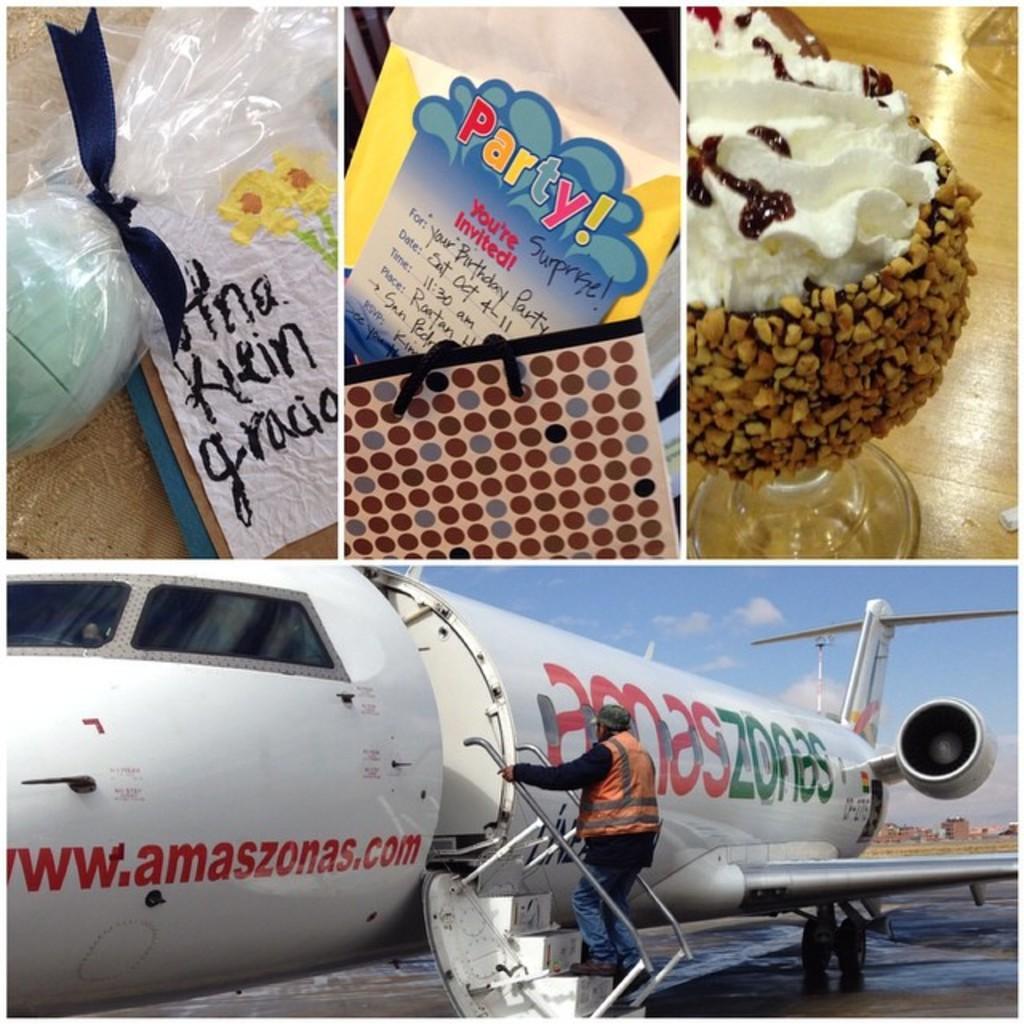Can you describe this image briefly? In this image we can see four pictures. In the first picture we can see an object kept in the cover and a card on which some text is written. In the second picture we can see a cover on which we can see some text is written is kept in the bag. In the third picture we can see a food item kept in the glass which is placed on the wooden table. In the fourth image we can see a person is standing on the steps of an airplane which is on the ground and in the background we can see the sky with clouds. 